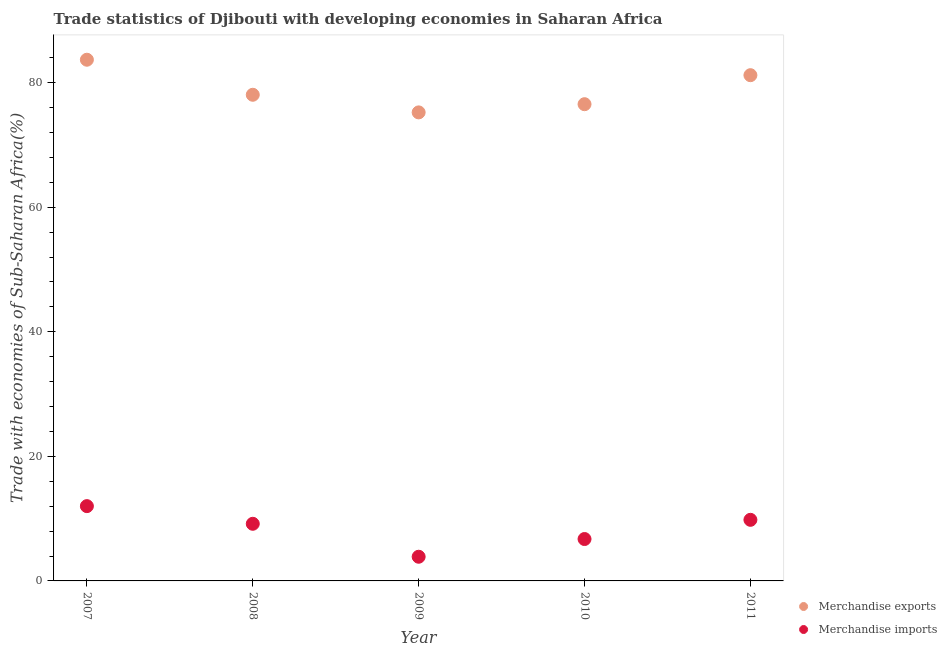Is the number of dotlines equal to the number of legend labels?
Keep it short and to the point. Yes. What is the merchandise exports in 2011?
Offer a very short reply. 81.19. Across all years, what is the maximum merchandise imports?
Give a very brief answer. 12.01. Across all years, what is the minimum merchandise exports?
Provide a short and direct response. 75.22. What is the total merchandise exports in the graph?
Keep it short and to the point. 394.67. What is the difference between the merchandise imports in 2009 and that in 2011?
Offer a very short reply. -5.93. What is the difference between the merchandise exports in 2007 and the merchandise imports in 2010?
Give a very brief answer. 76.95. What is the average merchandise exports per year?
Ensure brevity in your answer.  78.93. In the year 2007, what is the difference between the merchandise exports and merchandise imports?
Offer a terse response. 71.67. In how many years, is the merchandise imports greater than 40 %?
Ensure brevity in your answer.  0. What is the ratio of the merchandise exports in 2010 to that in 2011?
Your answer should be compact. 0.94. Is the difference between the merchandise exports in 2008 and 2009 greater than the difference between the merchandise imports in 2008 and 2009?
Offer a terse response. No. What is the difference between the highest and the second highest merchandise imports?
Your response must be concise. 2.2. What is the difference between the highest and the lowest merchandise exports?
Keep it short and to the point. 8.45. In how many years, is the merchandise imports greater than the average merchandise imports taken over all years?
Give a very brief answer. 3. Is the sum of the merchandise exports in 2009 and 2010 greater than the maximum merchandise imports across all years?
Provide a succinct answer. Yes. How many dotlines are there?
Keep it short and to the point. 2. How many years are there in the graph?
Your answer should be compact. 5. What is the difference between two consecutive major ticks on the Y-axis?
Offer a very short reply. 20. Does the graph contain grids?
Ensure brevity in your answer.  No. What is the title of the graph?
Provide a short and direct response. Trade statistics of Djibouti with developing economies in Saharan Africa. Does "Exports of goods" appear as one of the legend labels in the graph?
Your response must be concise. No. What is the label or title of the X-axis?
Give a very brief answer. Year. What is the label or title of the Y-axis?
Keep it short and to the point. Trade with economies of Sub-Saharan Africa(%). What is the Trade with economies of Sub-Saharan Africa(%) of Merchandise exports in 2007?
Keep it short and to the point. 83.67. What is the Trade with economies of Sub-Saharan Africa(%) in Merchandise imports in 2007?
Ensure brevity in your answer.  12.01. What is the Trade with economies of Sub-Saharan Africa(%) of Merchandise exports in 2008?
Keep it short and to the point. 78.05. What is the Trade with economies of Sub-Saharan Africa(%) in Merchandise imports in 2008?
Your response must be concise. 9.17. What is the Trade with economies of Sub-Saharan Africa(%) of Merchandise exports in 2009?
Your answer should be very brief. 75.22. What is the Trade with economies of Sub-Saharan Africa(%) in Merchandise imports in 2009?
Provide a succinct answer. 3.88. What is the Trade with economies of Sub-Saharan Africa(%) in Merchandise exports in 2010?
Offer a very short reply. 76.54. What is the Trade with economies of Sub-Saharan Africa(%) in Merchandise imports in 2010?
Offer a terse response. 6.73. What is the Trade with economies of Sub-Saharan Africa(%) in Merchandise exports in 2011?
Offer a terse response. 81.19. What is the Trade with economies of Sub-Saharan Africa(%) in Merchandise imports in 2011?
Offer a terse response. 9.81. Across all years, what is the maximum Trade with economies of Sub-Saharan Africa(%) in Merchandise exports?
Offer a very short reply. 83.67. Across all years, what is the maximum Trade with economies of Sub-Saharan Africa(%) of Merchandise imports?
Ensure brevity in your answer.  12.01. Across all years, what is the minimum Trade with economies of Sub-Saharan Africa(%) of Merchandise exports?
Make the answer very short. 75.22. Across all years, what is the minimum Trade with economies of Sub-Saharan Africa(%) of Merchandise imports?
Offer a terse response. 3.88. What is the total Trade with economies of Sub-Saharan Africa(%) in Merchandise exports in the graph?
Keep it short and to the point. 394.67. What is the total Trade with economies of Sub-Saharan Africa(%) of Merchandise imports in the graph?
Your response must be concise. 41.6. What is the difference between the Trade with economies of Sub-Saharan Africa(%) of Merchandise exports in 2007 and that in 2008?
Keep it short and to the point. 5.63. What is the difference between the Trade with economies of Sub-Saharan Africa(%) in Merchandise imports in 2007 and that in 2008?
Ensure brevity in your answer.  2.84. What is the difference between the Trade with economies of Sub-Saharan Africa(%) in Merchandise exports in 2007 and that in 2009?
Offer a terse response. 8.45. What is the difference between the Trade with economies of Sub-Saharan Africa(%) in Merchandise imports in 2007 and that in 2009?
Provide a succinct answer. 8.13. What is the difference between the Trade with economies of Sub-Saharan Africa(%) of Merchandise exports in 2007 and that in 2010?
Your answer should be very brief. 7.14. What is the difference between the Trade with economies of Sub-Saharan Africa(%) of Merchandise imports in 2007 and that in 2010?
Ensure brevity in your answer.  5.28. What is the difference between the Trade with economies of Sub-Saharan Africa(%) in Merchandise exports in 2007 and that in 2011?
Provide a short and direct response. 2.48. What is the difference between the Trade with economies of Sub-Saharan Africa(%) in Merchandise imports in 2007 and that in 2011?
Make the answer very short. 2.2. What is the difference between the Trade with economies of Sub-Saharan Africa(%) of Merchandise exports in 2008 and that in 2009?
Your answer should be very brief. 2.83. What is the difference between the Trade with economies of Sub-Saharan Africa(%) of Merchandise imports in 2008 and that in 2009?
Your response must be concise. 5.29. What is the difference between the Trade with economies of Sub-Saharan Africa(%) of Merchandise exports in 2008 and that in 2010?
Offer a very short reply. 1.51. What is the difference between the Trade with economies of Sub-Saharan Africa(%) of Merchandise imports in 2008 and that in 2010?
Ensure brevity in your answer.  2.45. What is the difference between the Trade with economies of Sub-Saharan Africa(%) of Merchandise exports in 2008 and that in 2011?
Your answer should be compact. -3.15. What is the difference between the Trade with economies of Sub-Saharan Africa(%) of Merchandise imports in 2008 and that in 2011?
Your answer should be very brief. -0.64. What is the difference between the Trade with economies of Sub-Saharan Africa(%) in Merchandise exports in 2009 and that in 2010?
Your answer should be compact. -1.32. What is the difference between the Trade with economies of Sub-Saharan Africa(%) in Merchandise imports in 2009 and that in 2010?
Keep it short and to the point. -2.84. What is the difference between the Trade with economies of Sub-Saharan Africa(%) of Merchandise exports in 2009 and that in 2011?
Offer a terse response. -5.97. What is the difference between the Trade with economies of Sub-Saharan Africa(%) in Merchandise imports in 2009 and that in 2011?
Give a very brief answer. -5.93. What is the difference between the Trade with economies of Sub-Saharan Africa(%) in Merchandise exports in 2010 and that in 2011?
Your response must be concise. -4.66. What is the difference between the Trade with economies of Sub-Saharan Africa(%) in Merchandise imports in 2010 and that in 2011?
Ensure brevity in your answer.  -3.08. What is the difference between the Trade with economies of Sub-Saharan Africa(%) in Merchandise exports in 2007 and the Trade with economies of Sub-Saharan Africa(%) in Merchandise imports in 2008?
Keep it short and to the point. 74.5. What is the difference between the Trade with economies of Sub-Saharan Africa(%) in Merchandise exports in 2007 and the Trade with economies of Sub-Saharan Africa(%) in Merchandise imports in 2009?
Keep it short and to the point. 79.79. What is the difference between the Trade with economies of Sub-Saharan Africa(%) in Merchandise exports in 2007 and the Trade with economies of Sub-Saharan Africa(%) in Merchandise imports in 2010?
Ensure brevity in your answer.  76.95. What is the difference between the Trade with economies of Sub-Saharan Africa(%) in Merchandise exports in 2007 and the Trade with economies of Sub-Saharan Africa(%) in Merchandise imports in 2011?
Provide a succinct answer. 73.87. What is the difference between the Trade with economies of Sub-Saharan Africa(%) of Merchandise exports in 2008 and the Trade with economies of Sub-Saharan Africa(%) of Merchandise imports in 2009?
Make the answer very short. 74.17. What is the difference between the Trade with economies of Sub-Saharan Africa(%) of Merchandise exports in 2008 and the Trade with economies of Sub-Saharan Africa(%) of Merchandise imports in 2010?
Your answer should be very brief. 71.32. What is the difference between the Trade with economies of Sub-Saharan Africa(%) of Merchandise exports in 2008 and the Trade with economies of Sub-Saharan Africa(%) of Merchandise imports in 2011?
Keep it short and to the point. 68.24. What is the difference between the Trade with economies of Sub-Saharan Africa(%) of Merchandise exports in 2009 and the Trade with economies of Sub-Saharan Africa(%) of Merchandise imports in 2010?
Provide a short and direct response. 68.49. What is the difference between the Trade with economies of Sub-Saharan Africa(%) in Merchandise exports in 2009 and the Trade with economies of Sub-Saharan Africa(%) in Merchandise imports in 2011?
Your response must be concise. 65.41. What is the difference between the Trade with economies of Sub-Saharan Africa(%) of Merchandise exports in 2010 and the Trade with economies of Sub-Saharan Africa(%) of Merchandise imports in 2011?
Offer a very short reply. 66.73. What is the average Trade with economies of Sub-Saharan Africa(%) in Merchandise exports per year?
Your answer should be compact. 78.93. What is the average Trade with economies of Sub-Saharan Africa(%) in Merchandise imports per year?
Provide a short and direct response. 8.32. In the year 2007, what is the difference between the Trade with economies of Sub-Saharan Africa(%) of Merchandise exports and Trade with economies of Sub-Saharan Africa(%) of Merchandise imports?
Offer a very short reply. 71.67. In the year 2008, what is the difference between the Trade with economies of Sub-Saharan Africa(%) in Merchandise exports and Trade with economies of Sub-Saharan Africa(%) in Merchandise imports?
Offer a terse response. 68.88. In the year 2009, what is the difference between the Trade with economies of Sub-Saharan Africa(%) in Merchandise exports and Trade with economies of Sub-Saharan Africa(%) in Merchandise imports?
Offer a very short reply. 71.34. In the year 2010, what is the difference between the Trade with economies of Sub-Saharan Africa(%) of Merchandise exports and Trade with economies of Sub-Saharan Africa(%) of Merchandise imports?
Your answer should be very brief. 69.81. In the year 2011, what is the difference between the Trade with economies of Sub-Saharan Africa(%) in Merchandise exports and Trade with economies of Sub-Saharan Africa(%) in Merchandise imports?
Keep it short and to the point. 71.38. What is the ratio of the Trade with economies of Sub-Saharan Africa(%) in Merchandise exports in 2007 to that in 2008?
Ensure brevity in your answer.  1.07. What is the ratio of the Trade with economies of Sub-Saharan Africa(%) in Merchandise imports in 2007 to that in 2008?
Provide a short and direct response. 1.31. What is the ratio of the Trade with economies of Sub-Saharan Africa(%) in Merchandise exports in 2007 to that in 2009?
Provide a succinct answer. 1.11. What is the ratio of the Trade with economies of Sub-Saharan Africa(%) in Merchandise imports in 2007 to that in 2009?
Your response must be concise. 3.09. What is the ratio of the Trade with economies of Sub-Saharan Africa(%) in Merchandise exports in 2007 to that in 2010?
Provide a short and direct response. 1.09. What is the ratio of the Trade with economies of Sub-Saharan Africa(%) of Merchandise imports in 2007 to that in 2010?
Ensure brevity in your answer.  1.79. What is the ratio of the Trade with economies of Sub-Saharan Africa(%) in Merchandise exports in 2007 to that in 2011?
Give a very brief answer. 1.03. What is the ratio of the Trade with economies of Sub-Saharan Africa(%) of Merchandise imports in 2007 to that in 2011?
Offer a terse response. 1.22. What is the ratio of the Trade with economies of Sub-Saharan Africa(%) of Merchandise exports in 2008 to that in 2009?
Provide a succinct answer. 1.04. What is the ratio of the Trade with economies of Sub-Saharan Africa(%) of Merchandise imports in 2008 to that in 2009?
Your answer should be very brief. 2.36. What is the ratio of the Trade with economies of Sub-Saharan Africa(%) of Merchandise exports in 2008 to that in 2010?
Provide a succinct answer. 1.02. What is the ratio of the Trade with economies of Sub-Saharan Africa(%) in Merchandise imports in 2008 to that in 2010?
Keep it short and to the point. 1.36. What is the ratio of the Trade with economies of Sub-Saharan Africa(%) of Merchandise exports in 2008 to that in 2011?
Your answer should be compact. 0.96. What is the ratio of the Trade with economies of Sub-Saharan Africa(%) of Merchandise imports in 2008 to that in 2011?
Offer a very short reply. 0.94. What is the ratio of the Trade with economies of Sub-Saharan Africa(%) in Merchandise exports in 2009 to that in 2010?
Keep it short and to the point. 0.98. What is the ratio of the Trade with economies of Sub-Saharan Africa(%) in Merchandise imports in 2009 to that in 2010?
Give a very brief answer. 0.58. What is the ratio of the Trade with economies of Sub-Saharan Africa(%) in Merchandise exports in 2009 to that in 2011?
Keep it short and to the point. 0.93. What is the ratio of the Trade with economies of Sub-Saharan Africa(%) in Merchandise imports in 2009 to that in 2011?
Offer a very short reply. 0.4. What is the ratio of the Trade with economies of Sub-Saharan Africa(%) in Merchandise exports in 2010 to that in 2011?
Provide a short and direct response. 0.94. What is the ratio of the Trade with economies of Sub-Saharan Africa(%) of Merchandise imports in 2010 to that in 2011?
Your response must be concise. 0.69. What is the difference between the highest and the second highest Trade with economies of Sub-Saharan Africa(%) in Merchandise exports?
Keep it short and to the point. 2.48. What is the difference between the highest and the second highest Trade with economies of Sub-Saharan Africa(%) in Merchandise imports?
Your response must be concise. 2.2. What is the difference between the highest and the lowest Trade with economies of Sub-Saharan Africa(%) in Merchandise exports?
Offer a very short reply. 8.45. What is the difference between the highest and the lowest Trade with economies of Sub-Saharan Africa(%) in Merchandise imports?
Ensure brevity in your answer.  8.13. 